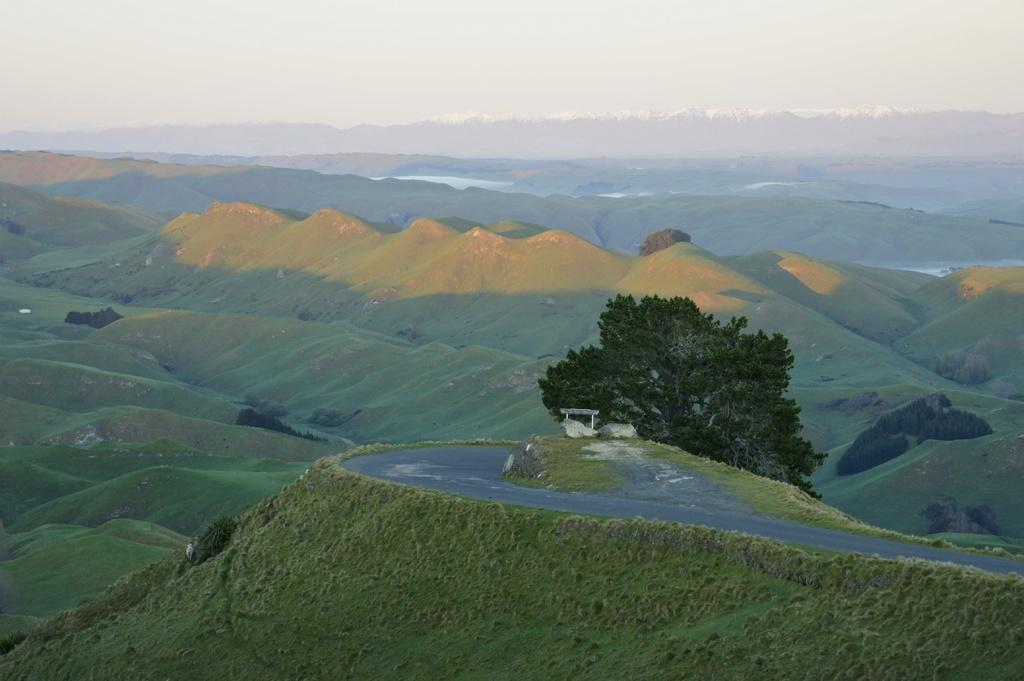What type of landscape is depicted in the image? The image features hills. What can be seen growing on the hills? There is grass and plants on the hills. Is there any infrastructure visible on the hills? Yes, there is a road on one of the hills. Are there any trees in the image? Yes, there is a tree beside the road. What is visible at the top of the image? The sky is visible at the top of the image. Can you see any donkeys grazing on the grass in the image? There are no donkeys present in the image; it features hills with grass and plants. What type of feather can be seen falling from the tree in the image? There is no feather falling from the tree in the image; there is only a tree beside the road. 